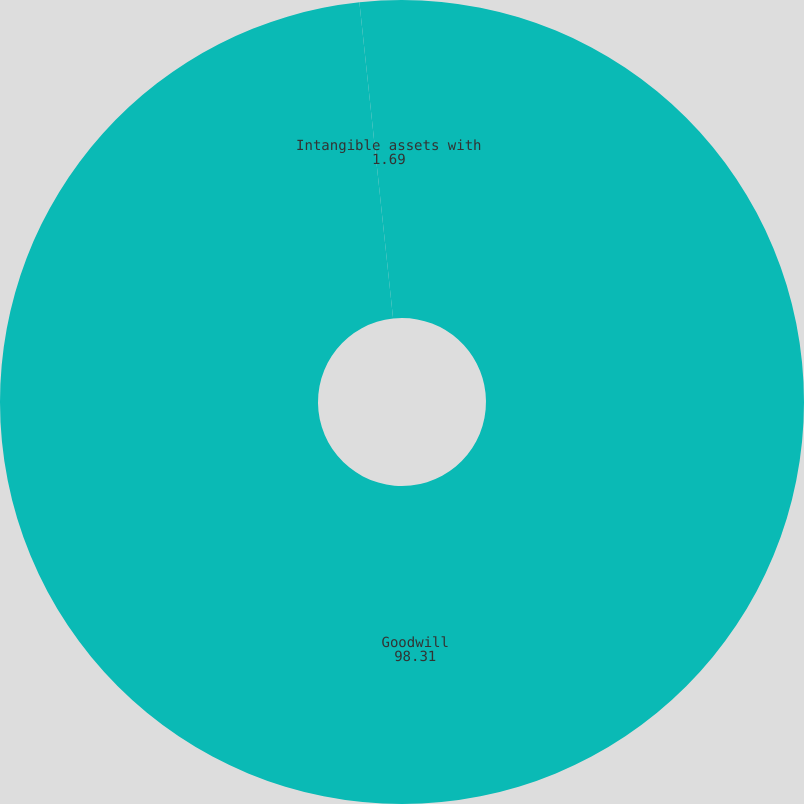<chart> <loc_0><loc_0><loc_500><loc_500><pie_chart><fcel>Goodwill<fcel>Intangible assets with<nl><fcel>98.31%<fcel>1.69%<nl></chart> 